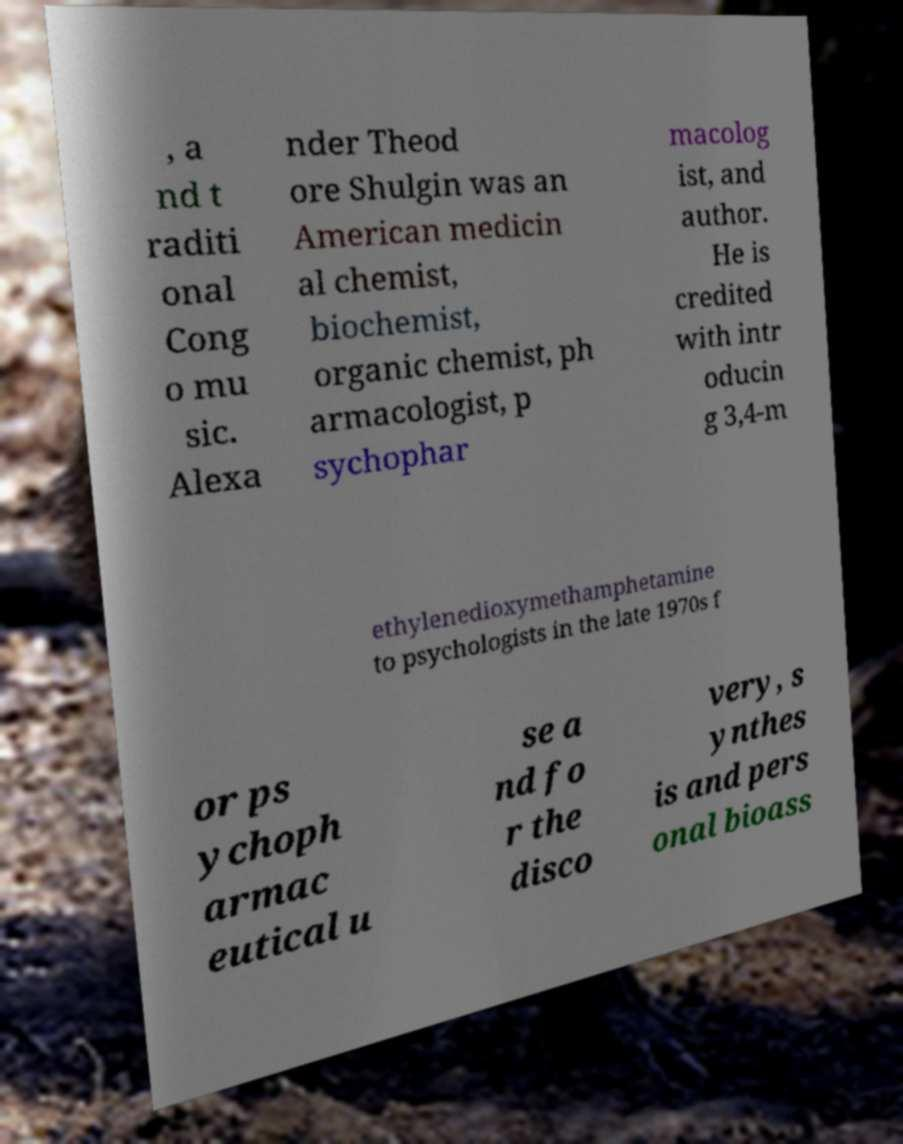Could you extract and type out the text from this image? , a nd t raditi onal Cong o mu sic. Alexa nder Theod ore Shulgin was an American medicin al chemist, biochemist, organic chemist, ph armacologist, p sychophar macolog ist, and author. He is credited with intr oducin g 3,4-m ethylenedioxymethamphetamine to psychologists in the late 1970s f or ps ychoph armac eutical u se a nd fo r the disco very, s ynthes is and pers onal bioass 